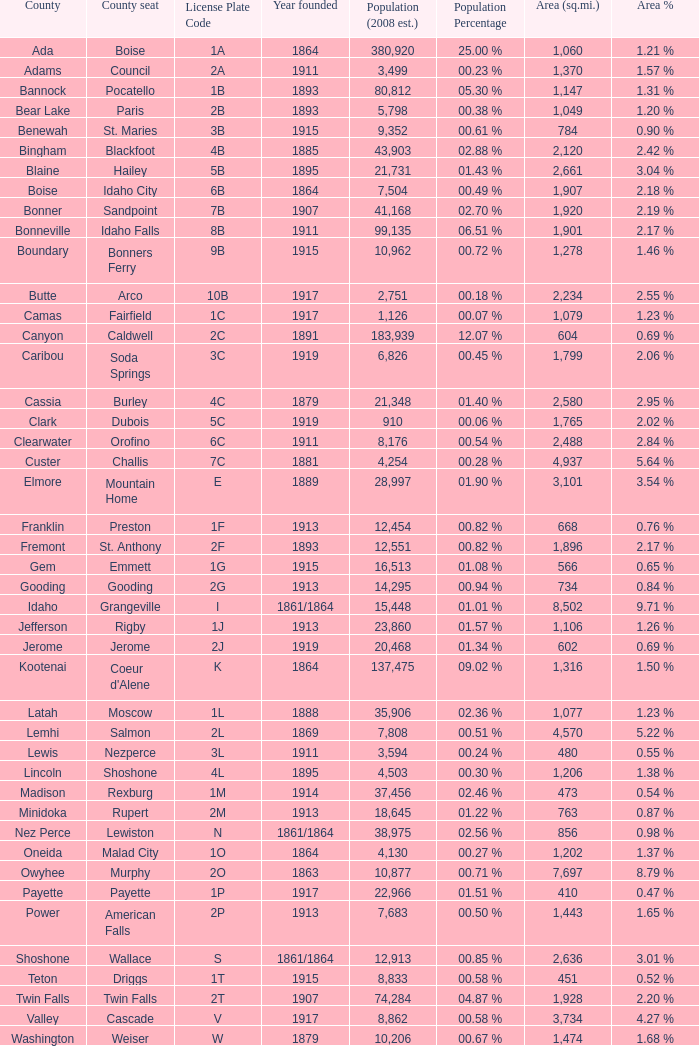What is the nation's location for the license plate code 5c? Dubois. 